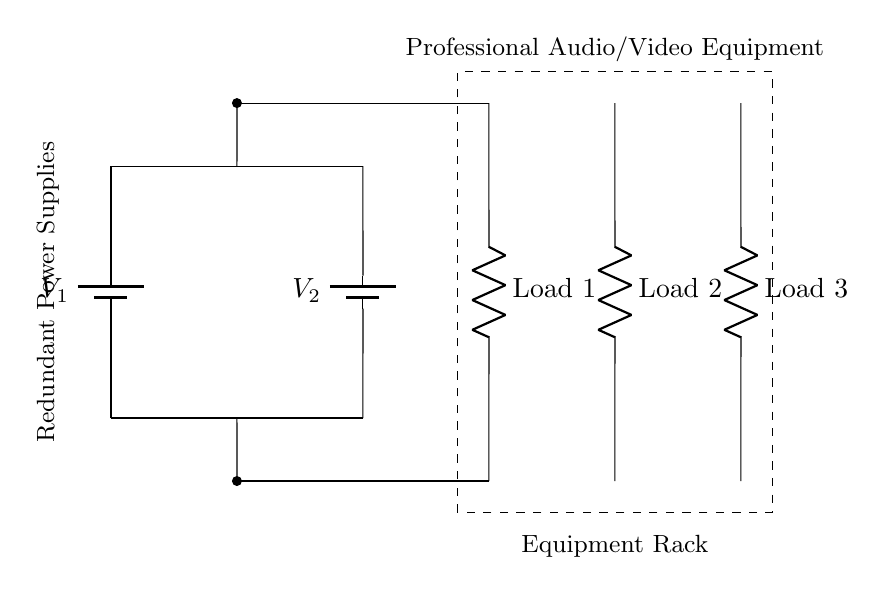What are the power sources in the circuit? The circuit contains two batteries labeled V1 and V2, which serve as the redundant power sources. Each battery is connected to the load circuitry in parallel, ensuring that there is always a power source available even if one fails.
Answer: V1, V2 How many loads are connected to the power supplies? There are three loads connected to the power supplies, indicated as Load 1, Load 2, and Load 3 on the right side of the circuit. Each load is connected to the common supply line formed by the parallel arrangement of the batteries.
Answer: 3 What is the advantage of using a parallel power supply configuration? The parallel configuration allows for redundancy, meaning that if one power source fails, the other can continue to provide power to the loads without interruption. This is crucial in professional audio/video equipment, as consistent power is essential for operation.
Answer: Redundancy What happens to the voltage across the loads if one battery fails? The voltage across the loads remains the same as long as at least one battery is functioning because parallel configurations maintain the same voltage across all connected components. Thus, if one battery fails, the other battery continues to supply the full voltage to all loads.
Answer: Remains the same What is the purpose of the dashed rectangle in the diagram? The dashed rectangle represents the equipment rack that houses the redundant power supplies and the loads. It visually groups these components together, indicating that they are part of the same organizational structure or system within the audio/video equipment setup.
Answer: Equipment rack 